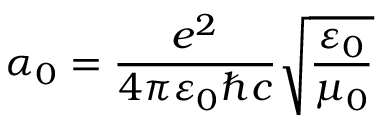<formula> <loc_0><loc_0><loc_500><loc_500>\alpha _ { 0 } = \frac { e ^ { 2 } } { 4 \pi \varepsilon _ { 0 } \hbar { c } } \sqrt { \frac { \varepsilon _ { 0 } } { \mu _ { 0 } } }</formula> 